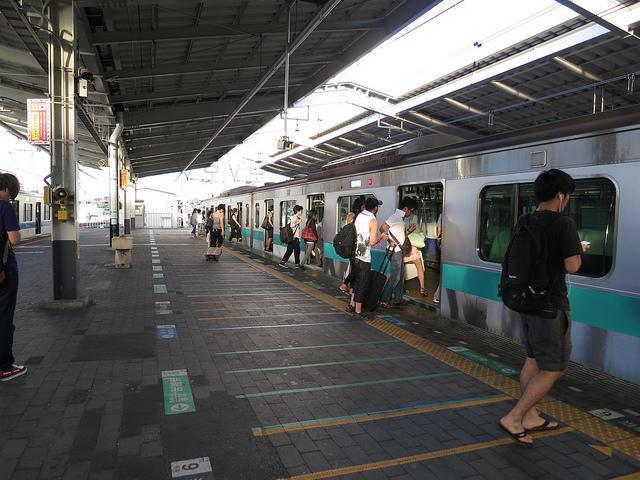How many people are in the photo?
Give a very brief answer. 4. How many bunches of bananas appear in the photo?
Give a very brief answer. 0. 